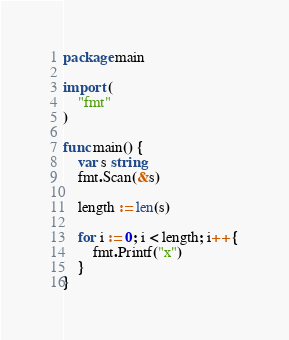Convert code to text. <code><loc_0><loc_0><loc_500><loc_500><_Go_>package main

import (
	"fmt"
)

func main() {
	var s string
	fmt.Scan(&s)
	
	length := len(s)
	
	for i := 0; i < length; i++ {
		fmt.Printf("x")
	}
}</code> 